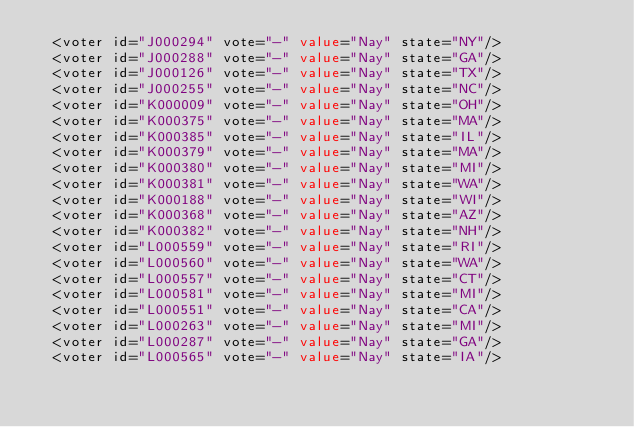Convert code to text. <code><loc_0><loc_0><loc_500><loc_500><_XML_>  <voter id="J000294" vote="-" value="Nay" state="NY"/>
  <voter id="J000288" vote="-" value="Nay" state="GA"/>
  <voter id="J000126" vote="-" value="Nay" state="TX"/>
  <voter id="J000255" vote="-" value="Nay" state="NC"/>
  <voter id="K000009" vote="-" value="Nay" state="OH"/>
  <voter id="K000375" vote="-" value="Nay" state="MA"/>
  <voter id="K000385" vote="-" value="Nay" state="IL"/>
  <voter id="K000379" vote="-" value="Nay" state="MA"/>
  <voter id="K000380" vote="-" value="Nay" state="MI"/>
  <voter id="K000381" vote="-" value="Nay" state="WA"/>
  <voter id="K000188" vote="-" value="Nay" state="WI"/>
  <voter id="K000368" vote="-" value="Nay" state="AZ"/>
  <voter id="K000382" vote="-" value="Nay" state="NH"/>
  <voter id="L000559" vote="-" value="Nay" state="RI"/>
  <voter id="L000560" vote="-" value="Nay" state="WA"/>
  <voter id="L000557" vote="-" value="Nay" state="CT"/>
  <voter id="L000581" vote="-" value="Nay" state="MI"/>
  <voter id="L000551" vote="-" value="Nay" state="CA"/>
  <voter id="L000263" vote="-" value="Nay" state="MI"/>
  <voter id="L000287" vote="-" value="Nay" state="GA"/>
  <voter id="L000565" vote="-" value="Nay" state="IA"/></code> 